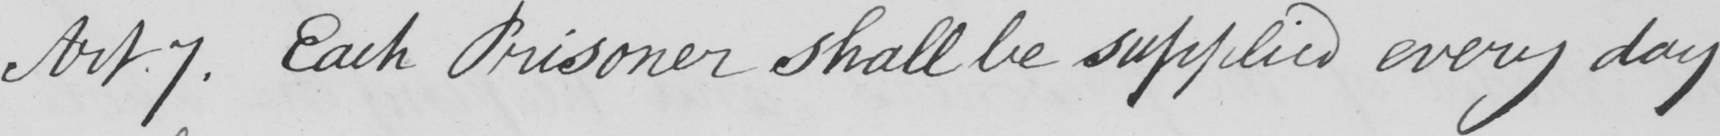Please transcribe the handwritten text in this image. Art.7. Each Prisoner shall be supplied every day 